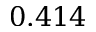Convert formula to latex. <formula><loc_0><loc_0><loc_500><loc_500>0 . 4 1 4</formula> 